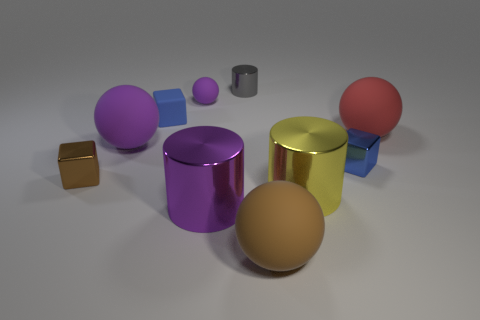Subtract all cubes. How many objects are left? 7 Add 7 large red things. How many large red things are left? 8 Add 4 purple shiny cylinders. How many purple shiny cylinders exist? 5 Subtract 0 blue balls. How many objects are left? 10 Subtract all small yellow balls. Subtract all large red spheres. How many objects are left? 9 